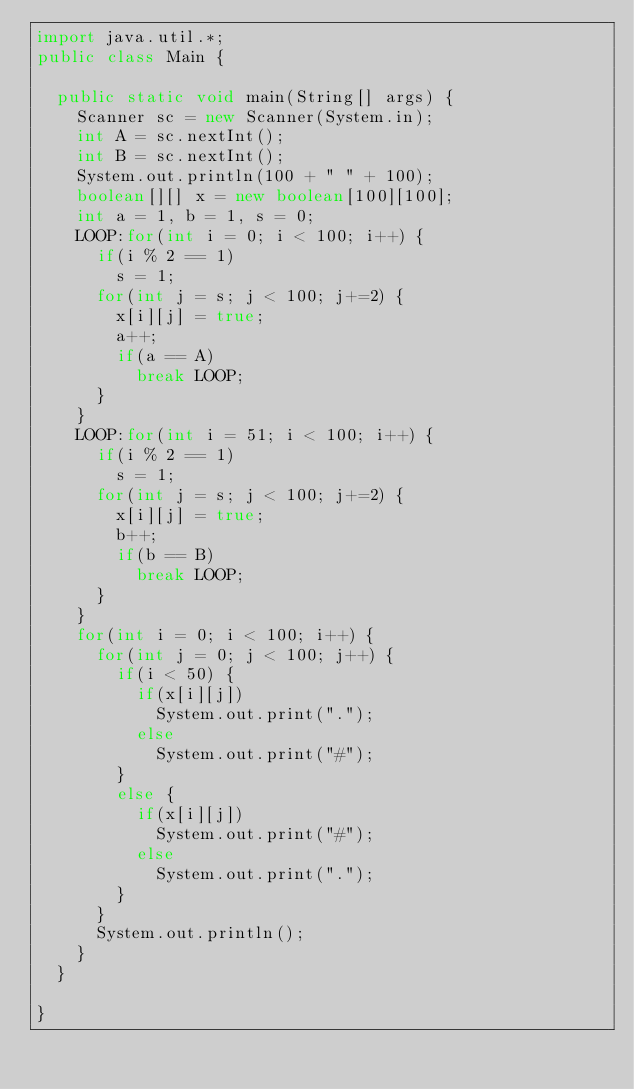Convert code to text. <code><loc_0><loc_0><loc_500><loc_500><_Java_>import java.util.*;
public class Main {

	public static void main(String[] args) {
		Scanner sc = new Scanner(System.in);
		int A = sc.nextInt();
		int B = sc.nextInt();
		System.out.println(100 + " " + 100);
		boolean[][] x = new boolean[100][100];
		int a = 1, b = 1, s = 0;
		LOOP:for(int i = 0; i < 100; i++) {
			if(i % 2 == 1)
				s = 1;
			for(int j = s; j < 100; j+=2) {
				x[i][j] = true;
				a++;
				if(a == A)
					break LOOP;
			}
		}
		LOOP:for(int i = 51; i < 100; i++) {
			if(i % 2 == 1)
				s = 1;
			for(int j = s; j < 100; j+=2) {
				x[i][j] = true;
				b++;
				if(b == B)
					break LOOP;
			}
		}
		for(int i = 0; i < 100; i++) {
			for(int j = 0; j < 100; j++) {
				if(i < 50) {
					if(x[i][j])
						System.out.print(".");
					else
						System.out.print("#");
				}
				else {
					if(x[i][j])
						System.out.print("#");
					else
						System.out.print(".");
				}
			}
			System.out.println();
		}
	}

}</code> 